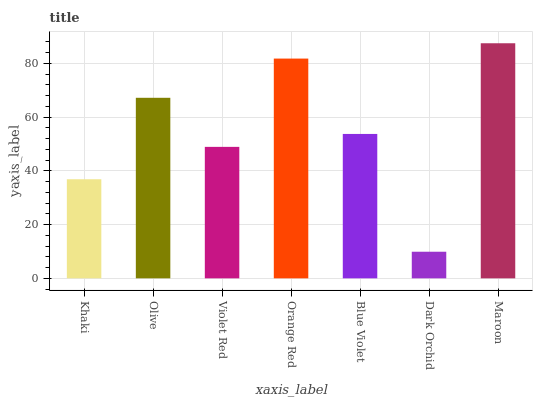Is Dark Orchid the minimum?
Answer yes or no. Yes. Is Maroon the maximum?
Answer yes or no. Yes. Is Olive the minimum?
Answer yes or no. No. Is Olive the maximum?
Answer yes or no. No. Is Olive greater than Khaki?
Answer yes or no. Yes. Is Khaki less than Olive?
Answer yes or no. Yes. Is Khaki greater than Olive?
Answer yes or no. No. Is Olive less than Khaki?
Answer yes or no. No. Is Blue Violet the high median?
Answer yes or no. Yes. Is Blue Violet the low median?
Answer yes or no. Yes. Is Khaki the high median?
Answer yes or no. No. Is Violet Red the low median?
Answer yes or no. No. 